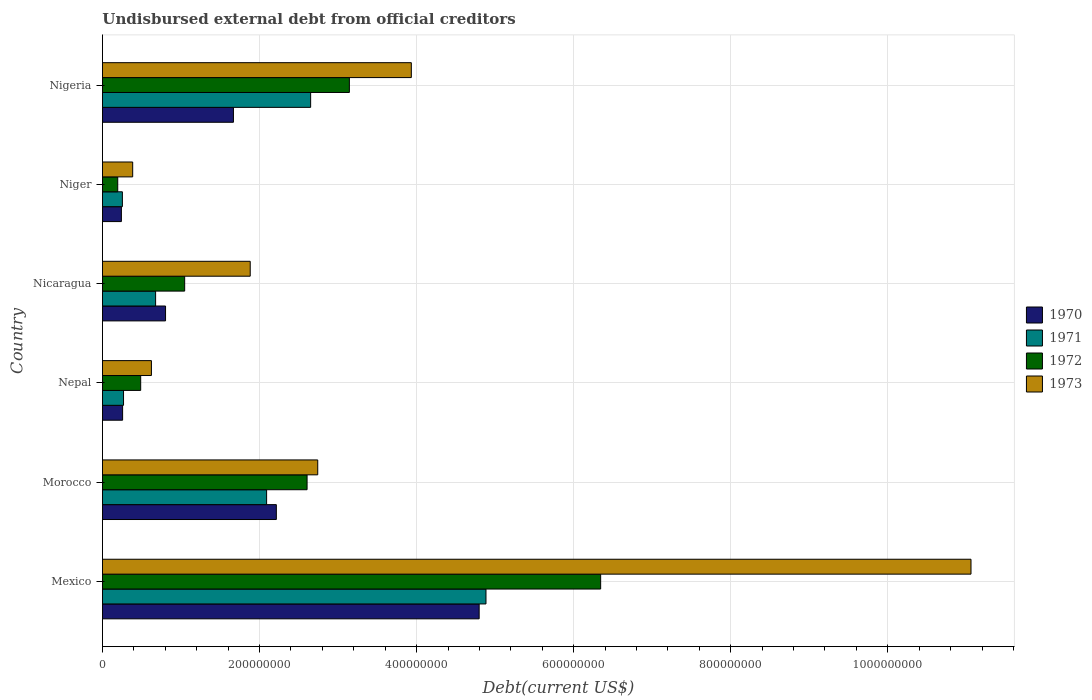How many different coloured bars are there?
Provide a succinct answer. 4. How many groups of bars are there?
Make the answer very short. 6. How many bars are there on the 5th tick from the top?
Provide a succinct answer. 4. What is the label of the 3rd group of bars from the top?
Your answer should be very brief. Nicaragua. In how many cases, is the number of bars for a given country not equal to the number of legend labels?
Make the answer very short. 0. What is the total debt in 1972 in Nigeria?
Your answer should be compact. 3.14e+08. Across all countries, what is the maximum total debt in 1972?
Provide a succinct answer. 6.34e+08. Across all countries, what is the minimum total debt in 1972?
Ensure brevity in your answer.  1.94e+07. In which country was the total debt in 1972 maximum?
Ensure brevity in your answer.  Mexico. In which country was the total debt in 1973 minimum?
Make the answer very short. Niger. What is the total total debt in 1970 in the graph?
Provide a short and direct response. 9.98e+08. What is the difference between the total debt in 1973 in Morocco and that in Nigeria?
Give a very brief answer. -1.19e+08. What is the difference between the total debt in 1970 in Nicaragua and the total debt in 1971 in Mexico?
Your answer should be very brief. -4.08e+08. What is the average total debt in 1970 per country?
Your response must be concise. 1.66e+08. What is the difference between the total debt in 1971 and total debt in 1970 in Nepal?
Your answer should be compact. 1.17e+06. In how many countries, is the total debt in 1971 greater than 920000000 US$?
Offer a very short reply. 0. What is the ratio of the total debt in 1970 in Nicaragua to that in Nigeria?
Provide a short and direct response. 0.48. Is the total debt in 1970 in Morocco less than that in Niger?
Your response must be concise. No. Is the difference between the total debt in 1971 in Nicaragua and Nigeria greater than the difference between the total debt in 1970 in Nicaragua and Nigeria?
Make the answer very short. No. What is the difference between the highest and the second highest total debt in 1971?
Offer a very short reply. 2.23e+08. What is the difference between the highest and the lowest total debt in 1972?
Offer a terse response. 6.15e+08. In how many countries, is the total debt in 1973 greater than the average total debt in 1973 taken over all countries?
Your answer should be very brief. 2. Is the sum of the total debt in 1970 in Nepal and Nigeria greater than the maximum total debt in 1971 across all countries?
Your answer should be compact. No. Is it the case that in every country, the sum of the total debt in 1970 and total debt in 1971 is greater than the total debt in 1972?
Give a very brief answer. Yes. How many countries are there in the graph?
Your answer should be compact. 6. Are the values on the major ticks of X-axis written in scientific E-notation?
Give a very brief answer. No. Does the graph contain any zero values?
Offer a terse response. No. Does the graph contain grids?
Your response must be concise. Yes. How are the legend labels stacked?
Provide a short and direct response. Vertical. What is the title of the graph?
Your response must be concise. Undisbursed external debt from official creditors. Does "2015" appear as one of the legend labels in the graph?
Provide a short and direct response. No. What is the label or title of the X-axis?
Give a very brief answer. Debt(current US$). What is the Debt(current US$) in 1970 in Mexico?
Offer a very short reply. 4.80e+08. What is the Debt(current US$) in 1971 in Mexico?
Provide a short and direct response. 4.88e+08. What is the Debt(current US$) in 1972 in Mexico?
Keep it short and to the point. 6.34e+08. What is the Debt(current US$) of 1973 in Mexico?
Give a very brief answer. 1.11e+09. What is the Debt(current US$) in 1970 in Morocco?
Ensure brevity in your answer.  2.21e+08. What is the Debt(current US$) of 1971 in Morocco?
Your answer should be compact. 2.09e+08. What is the Debt(current US$) of 1972 in Morocco?
Give a very brief answer. 2.61e+08. What is the Debt(current US$) in 1973 in Morocco?
Provide a short and direct response. 2.74e+08. What is the Debt(current US$) in 1970 in Nepal?
Offer a terse response. 2.57e+07. What is the Debt(current US$) in 1971 in Nepal?
Offer a very short reply. 2.68e+07. What is the Debt(current US$) of 1972 in Nepal?
Offer a terse response. 4.87e+07. What is the Debt(current US$) in 1973 in Nepal?
Keep it short and to the point. 6.23e+07. What is the Debt(current US$) in 1970 in Nicaragua?
Offer a terse response. 8.03e+07. What is the Debt(current US$) of 1971 in Nicaragua?
Keep it short and to the point. 6.77e+07. What is the Debt(current US$) of 1972 in Nicaragua?
Offer a very short reply. 1.05e+08. What is the Debt(current US$) of 1973 in Nicaragua?
Offer a terse response. 1.88e+08. What is the Debt(current US$) of 1970 in Niger?
Provide a short and direct response. 2.41e+07. What is the Debt(current US$) of 1971 in Niger?
Make the answer very short. 2.54e+07. What is the Debt(current US$) of 1972 in Niger?
Offer a terse response. 1.94e+07. What is the Debt(current US$) in 1973 in Niger?
Give a very brief answer. 3.85e+07. What is the Debt(current US$) of 1970 in Nigeria?
Give a very brief answer. 1.67e+08. What is the Debt(current US$) of 1971 in Nigeria?
Make the answer very short. 2.65e+08. What is the Debt(current US$) of 1972 in Nigeria?
Offer a very short reply. 3.14e+08. What is the Debt(current US$) of 1973 in Nigeria?
Offer a terse response. 3.93e+08. Across all countries, what is the maximum Debt(current US$) of 1970?
Make the answer very short. 4.80e+08. Across all countries, what is the maximum Debt(current US$) of 1971?
Your answer should be very brief. 4.88e+08. Across all countries, what is the maximum Debt(current US$) of 1972?
Your answer should be compact. 6.34e+08. Across all countries, what is the maximum Debt(current US$) in 1973?
Give a very brief answer. 1.11e+09. Across all countries, what is the minimum Debt(current US$) of 1970?
Your response must be concise. 2.41e+07. Across all countries, what is the minimum Debt(current US$) of 1971?
Keep it short and to the point. 2.54e+07. Across all countries, what is the minimum Debt(current US$) of 1972?
Give a very brief answer. 1.94e+07. Across all countries, what is the minimum Debt(current US$) in 1973?
Make the answer very short. 3.85e+07. What is the total Debt(current US$) of 1970 in the graph?
Ensure brevity in your answer.  9.98e+08. What is the total Debt(current US$) in 1971 in the graph?
Make the answer very short. 1.08e+09. What is the total Debt(current US$) of 1972 in the graph?
Make the answer very short. 1.38e+09. What is the total Debt(current US$) of 1973 in the graph?
Provide a succinct answer. 2.06e+09. What is the difference between the Debt(current US$) of 1970 in Mexico and that in Morocco?
Offer a terse response. 2.58e+08. What is the difference between the Debt(current US$) in 1971 in Mexico and that in Morocco?
Offer a very short reply. 2.79e+08. What is the difference between the Debt(current US$) of 1972 in Mexico and that in Morocco?
Your answer should be compact. 3.74e+08. What is the difference between the Debt(current US$) in 1973 in Mexico and that in Morocco?
Provide a succinct answer. 8.32e+08. What is the difference between the Debt(current US$) in 1970 in Mexico and that in Nepal?
Offer a terse response. 4.54e+08. What is the difference between the Debt(current US$) of 1971 in Mexico and that in Nepal?
Provide a short and direct response. 4.62e+08. What is the difference between the Debt(current US$) of 1972 in Mexico and that in Nepal?
Offer a terse response. 5.86e+08. What is the difference between the Debt(current US$) of 1973 in Mexico and that in Nepal?
Provide a succinct answer. 1.04e+09. What is the difference between the Debt(current US$) of 1970 in Mexico and that in Nicaragua?
Your response must be concise. 3.99e+08. What is the difference between the Debt(current US$) in 1971 in Mexico and that in Nicaragua?
Offer a terse response. 4.21e+08. What is the difference between the Debt(current US$) in 1972 in Mexico and that in Nicaragua?
Provide a short and direct response. 5.30e+08. What is the difference between the Debt(current US$) in 1973 in Mexico and that in Nicaragua?
Provide a short and direct response. 9.18e+08. What is the difference between the Debt(current US$) of 1970 in Mexico and that in Niger?
Your response must be concise. 4.56e+08. What is the difference between the Debt(current US$) of 1971 in Mexico and that in Niger?
Keep it short and to the point. 4.63e+08. What is the difference between the Debt(current US$) in 1972 in Mexico and that in Niger?
Ensure brevity in your answer.  6.15e+08. What is the difference between the Debt(current US$) of 1973 in Mexico and that in Niger?
Your answer should be very brief. 1.07e+09. What is the difference between the Debt(current US$) in 1970 in Mexico and that in Nigeria?
Provide a short and direct response. 3.13e+08. What is the difference between the Debt(current US$) of 1971 in Mexico and that in Nigeria?
Offer a very short reply. 2.23e+08. What is the difference between the Debt(current US$) in 1972 in Mexico and that in Nigeria?
Your answer should be very brief. 3.20e+08. What is the difference between the Debt(current US$) in 1973 in Mexico and that in Nigeria?
Give a very brief answer. 7.13e+08. What is the difference between the Debt(current US$) in 1970 in Morocco and that in Nepal?
Ensure brevity in your answer.  1.96e+08. What is the difference between the Debt(current US$) in 1971 in Morocco and that in Nepal?
Give a very brief answer. 1.82e+08. What is the difference between the Debt(current US$) of 1972 in Morocco and that in Nepal?
Your answer should be compact. 2.12e+08. What is the difference between the Debt(current US$) in 1973 in Morocco and that in Nepal?
Offer a very short reply. 2.12e+08. What is the difference between the Debt(current US$) of 1970 in Morocco and that in Nicaragua?
Provide a succinct answer. 1.41e+08. What is the difference between the Debt(current US$) in 1971 in Morocco and that in Nicaragua?
Offer a very short reply. 1.41e+08. What is the difference between the Debt(current US$) in 1972 in Morocco and that in Nicaragua?
Offer a very short reply. 1.56e+08. What is the difference between the Debt(current US$) in 1973 in Morocco and that in Nicaragua?
Offer a very short reply. 8.60e+07. What is the difference between the Debt(current US$) of 1970 in Morocco and that in Niger?
Your answer should be very brief. 1.97e+08. What is the difference between the Debt(current US$) of 1971 in Morocco and that in Niger?
Provide a succinct answer. 1.84e+08. What is the difference between the Debt(current US$) of 1972 in Morocco and that in Niger?
Offer a terse response. 2.41e+08. What is the difference between the Debt(current US$) of 1973 in Morocco and that in Niger?
Give a very brief answer. 2.36e+08. What is the difference between the Debt(current US$) in 1970 in Morocco and that in Nigeria?
Your answer should be compact. 5.46e+07. What is the difference between the Debt(current US$) in 1971 in Morocco and that in Nigeria?
Your response must be concise. -5.61e+07. What is the difference between the Debt(current US$) in 1972 in Morocco and that in Nigeria?
Your answer should be very brief. -5.39e+07. What is the difference between the Debt(current US$) of 1973 in Morocco and that in Nigeria?
Offer a terse response. -1.19e+08. What is the difference between the Debt(current US$) of 1970 in Nepal and that in Nicaragua?
Your response must be concise. -5.47e+07. What is the difference between the Debt(current US$) in 1971 in Nepal and that in Nicaragua?
Provide a short and direct response. -4.08e+07. What is the difference between the Debt(current US$) in 1972 in Nepal and that in Nicaragua?
Keep it short and to the point. -5.60e+07. What is the difference between the Debt(current US$) in 1973 in Nepal and that in Nicaragua?
Offer a very short reply. -1.26e+08. What is the difference between the Debt(current US$) in 1970 in Nepal and that in Niger?
Your response must be concise. 1.55e+06. What is the difference between the Debt(current US$) in 1971 in Nepal and that in Niger?
Offer a terse response. 1.45e+06. What is the difference between the Debt(current US$) of 1972 in Nepal and that in Niger?
Provide a succinct answer. 2.92e+07. What is the difference between the Debt(current US$) of 1973 in Nepal and that in Niger?
Give a very brief answer. 2.39e+07. What is the difference between the Debt(current US$) of 1970 in Nepal and that in Nigeria?
Offer a very short reply. -1.41e+08. What is the difference between the Debt(current US$) of 1971 in Nepal and that in Nigeria?
Your response must be concise. -2.38e+08. What is the difference between the Debt(current US$) in 1972 in Nepal and that in Nigeria?
Keep it short and to the point. -2.66e+08. What is the difference between the Debt(current US$) in 1973 in Nepal and that in Nigeria?
Offer a terse response. -3.31e+08. What is the difference between the Debt(current US$) in 1970 in Nicaragua and that in Niger?
Give a very brief answer. 5.62e+07. What is the difference between the Debt(current US$) in 1971 in Nicaragua and that in Niger?
Your answer should be very brief. 4.23e+07. What is the difference between the Debt(current US$) in 1972 in Nicaragua and that in Niger?
Ensure brevity in your answer.  8.52e+07. What is the difference between the Debt(current US$) of 1973 in Nicaragua and that in Niger?
Offer a very short reply. 1.50e+08. What is the difference between the Debt(current US$) of 1970 in Nicaragua and that in Nigeria?
Offer a terse response. -8.65e+07. What is the difference between the Debt(current US$) in 1971 in Nicaragua and that in Nigeria?
Provide a succinct answer. -1.97e+08. What is the difference between the Debt(current US$) in 1972 in Nicaragua and that in Nigeria?
Provide a short and direct response. -2.10e+08. What is the difference between the Debt(current US$) in 1973 in Nicaragua and that in Nigeria?
Make the answer very short. -2.05e+08. What is the difference between the Debt(current US$) in 1970 in Niger and that in Nigeria?
Your response must be concise. -1.43e+08. What is the difference between the Debt(current US$) in 1971 in Niger and that in Nigeria?
Provide a succinct answer. -2.40e+08. What is the difference between the Debt(current US$) in 1972 in Niger and that in Nigeria?
Your answer should be compact. -2.95e+08. What is the difference between the Debt(current US$) in 1973 in Niger and that in Nigeria?
Provide a succinct answer. -3.55e+08. What is the difference between the Debt(current US$) in 1970 in Mexico and the Debt(current US$) in 1971 in Morocco?
Keep it short and to the point. 2.71e+08. What is the difference between the Debt(current US$) of 1970 in Mexico and the Debt(current US$) of 1972 in Morocco?
Keep it short and to the point. 2.19e+08. What is the difference between the Debt(current US$) of 1970 in Mexico and the Debt(current US$) of 1973 in Morocco?
Your answer should be very brief. 2.06e+08. What is the difference between the Debt(current US$) of 1971 in Mexico and the Debt(current US$) of 1972 in Morocco?
Give a very brief answer. 2.28e+08. What is the difference between the Debt(current US$) in 1971 in Mexico and the Debt(current US$) in 1973 in Morocco?
Your answer should be compact. 2.14e+08. What is the difference between the Debt(current US$) of 1972 in Mexico and the Debt(current US$) of 1973 in Morocco?
Give a very brief answer. 3.60e+08. What is the difference between the Debt(current US$) of 1970 in Mexico and the Debt(current US$) of 1971 in Nepal?
Offer a very short reply. 4.53e+08. What is the difference between the Debt(current US$) in 1970 in Mexico and the Debt(current US$) in 1972 in Nepal?
Your response must be concise. 4.31e+08. What is the difference between the Debt(current US$) in 1970 in Mexico and the Debt(current US$) in 1973 in Nepal?
Ensure brevity in your answer.  4.17e+08. What is the difference between the Debt(current US$) of 1971 in Mexico and the Debt(current US$) of 1972 in Nepal?
Make the answer very short. 4.40e+08. What is the difference between the Debt(current US$) in 1971 in Mexico and the Debt(current US$) in 1973 in Nepal?
Offer a very short reply. 4.26e+08. What is the difference between the Debt(current US$) of 1972 in Mexico and the Debt(current US$) of 1973 in Nepal?
Ensure brevity in your answer.  5.72e+08. What is the difference between the Debt(current US$) in 1970 in Mexico and the Debt(current US$) in 1971 in Nicaragua?
Your response must be concise. 4.12e+08. What is the difference between the Debt(current US$) in 1970 in Mexico and the Debt(current US$) in 1972 in Nicaragua?
Make the answer very short. 3.75e+08. What is the difference between the Debt(current US$) in 1970 in Mexico and the Debt(current US$) in 1973 in Nicaragua?
Provide a short and direct response. 2.92e+08. What is the difference between the Debt(current US$) in 1971 in Mexico and the Debt(current US$) in 1972 in Nicaragua?
Give a very brief answer. 3.84e+08. What is the difference between the Debt(current US$) of 1971 in Mexico and the Debt(current US$) of 1973 in Nicaragua?
Provide a succinct answer. 3.00e+08. What is the difference between the Debt(current US$) in 1972 in Mexico and the Debt(current US$) in 1973 in Nicaragua?
Keep it short and to the point. 4.46e+08. What is the difference between the Debt(current US$) in 1970 in Mexico and the Debt(current US$) in 1971 in Niger?
Offer a very short reply. 4.54e+08. What is the difference between the Debt(current US$) of 1970 in Mexico and the Debt(current US$) of 1972 in Niger?
Keep it short and to the point. 4.60e+08. What is the difference between the Debt(current US$) of 1970 in Mexico and the Debt(current US$) of 1973 in Niger?
Your answer should be very brief. 4.41e+08. What is the difference between the Debt(current US$) in 1971 in Mexico and the Debt(current US$) in 1972 in Niger?
Your answer should be very brief. 4.69e+08. What is the difference between the Debt(current US$) of 1971 in Mexico and the Debt(current US$) of 1973 in Niger?
Your answer should be very brief. 4.50e+08. What is the difference between the Debt(current US$) of 1972 in Mexico and the Debt(current US$) of 1973 in Niger?
Your answer should be very brief. 5.96e+08. What is the difference between the Debt(current US$) in 1970 in Mexico and the Debt(current US$) in 1971 in Nigeria?
Provide a succinct answer. 2.15e+08. What is the difference between the Debt(current US$) in 1970 in Mexico and the Debt(current US$) in 1972 in Nigeria?
Provide a succinct answer. 1.65e+08. What is the difference between the Debt(current US$) in 1970 in Mexico and the Debt(current US$) in 1973 in Nigeria?
Make the answer very short. 8.64e+07. What is the difference between the Debt(current US$) of 1971 in Mexico and the Debt(current US$) of 1972 in Nigeria?
Make the answer very short. 1.74e+08. What is the difference between the Debt(current US$) of 1971 in Mexico and the Debt(current US$) of 1973 in Nigeria?
Ensure brevity in your answer.  9.51e+07. What is the difference between the Debt(current US$) in 1972 in Mexico and the Debt(current US$) in 1973 in Nigeria?
Ensure brevity in your answer.  2.41e+08. What is the difference between the Debt(current US$) in 1970 in Morocco and the Debt(current US$) in 1971 in Nepal?
Provide a succinct answer. 1.95e+08. What is the difference between the Debt(current US$) in 1970 in Morocco and the Debt(current US$) in 1972 in Nepal?
Provide a short and direct response. 1.73e+08. What is the difference between the Debt(current US$) in 1970 in Morocco and the Debt(current US$) in 1973 in Nepal?
Your response must be concise. 1.59e+08. What is the difference between the Debt(current US$) of 1971 in Morocco and the Debt(current US$) of 1972 in Nepal?
Ensure brevity in your answer.  1.60e+08. What is the difference between the Debt(current US$) of 1971 in Morocco and the Debt(current US$) of 1973 in Nepal?
Give a very brief answer. 1.47e+08. What is the difference between the Debt(current US$) of 1972 in Morocco and the Debt(current US$) of 1973 in Nepal?
Your response must be concise. 1.98e+08. What is the difference between the Debt(current US$) in 1970 in Morocco and the Debt(current US$) in 1971 in Nicaragua?
Your answer should be compact. 1.54e+08. What is the difference between the Debt(current US$) in 1970 in Morocco and the Debt(current US$) in 1972 in Nicaragua?
Your answer should be very brief. 1.17e+08. What is the difference between the Debt(current US$) in 1970 in Morocco and the Debt(current US$) in 1973 in Nicaragua?
Give a very brief answer. 3.33e+07. What is the difference between the Debt(current US$) of 1971 in Morocco and the Debt(current US$) of 1972 in Nicaragua?
Your answer should be very brief. 1.04e+08. What is the difference between the Debt(current US$) in 1971 in Morocco and the Debt(current US$) in 1973 in Nicaragua?
Keep it short and to the point. 2.09e+07. What is the difference between the Debt(current US$) of 1972 in Morocco and the Debt(current US$) of 1973 in Nicaragua?
Your response must be concise. 7.24e+07. What is the difference between the Debt(current US$) in 1970 in Morocco and the Debt(current US$) in 1971 in Niger?
Provide a succinct answer. 1.96e+08. What is the difference between the Debt(current US$) of 1970 in Morocco and the Debt(current US$) of 1972 in Niger?
Provide a succinct answer. 2.02e+08. What is the difference between the Debt(current US$) in 1970 in Morocco and the Debt(current US$) in 1973 in Niger?
Make the answer very short. 1.83e+08. What is the difference between the Debt(current US$) of 1971 in Morocco and the Debt(current US$) of 1972 in Niger?
Offer a terse response. 1.90e+08. What is the difference between the Debt(current US$) of 1971 in Morocco and the Debt(current US$) of 1973 in Niger?
Offer a very short reply. 1.71e+08. What is the difference between the Debt(current US$) in 1972 in Morocco and the Debt(current US$) in 1973 in Niger?
Make the answer very short. 2.22e+08. What is the difference between the Debt(current US$) in 1970 in Morocco and the Debt(current US$) in 1971 in Nigeria?
Offer a terse response. -4.37e+07. What is the difference between the Debt(current US$) in 1970 in Morocco and the Debt(current US$) in 1972 in Nigeria?
Provide a short and direct response. -9.30e+07. What is the difference between the Debt(current US$) in 1970 in Morocco and the Debt(current US$) in 1973 in Nigeria?
Provide a short and direct response. -1.72e+08. What is the difference between the Debt(current US$) of 1971 in Morocco and the Debt(current US$) of 1972 in Nigeria?
Offer a very short reply. -1.05e+08. What is the difference between the Debt(current US$) of 1971 in Morocco and the Debt(current US$) of 1973 in Nigeria?
Provide a succinct answer. -1.84e+08. What is the difference between the Debt(current US$) of 1972 in Morocco and the Debt(current US$) of 1973 in Nigeria?
Keep it short and to the point. -1.33e+08. What is the difference between the Debt(current US$) of 1970 in Nepal and the Debt(current US$) of 1971 in Nicaragua?
Your response must be concise. -4.20e+07. What is the difference between the Debt(current US$) of 1970 in Nepal and the Debt(current US$) of 1972 in Nicaragua?
Give a very brief answer. -7.90e+07. What is the difference between the Debt(current US$) in 1970 in Nepal and the Debt(current US$) in 1973 in Nicaragua?
Make the answer very short. -1.62e+08. What is the difference between the Debt(current US$) in 1971 in Nepal and the Debt(current US$) in 1972 in Nicaragua?
Offer a very short reply. -7.78e+07. What is the difference between the Debt(current US$) of 1971 in Nepal and the Debt(current US$) of 1973 in Nicaragua?
Offer a very short reply. -1.61e+08. What is the difference between the Debt(current US$) in 1972 in Nepal and the Debt(current US$) in 1973 in Nicaragua?
Your response must be concise. -1.39e+08. What is the difference between the Debt(current US$) in 1970 in Nepal and the Debt(current US$) in 1971 in Niger?
Make the answer very short. 2.78e+05. What is the difference between the Debt(current US$) of 1970 in Nepal and the Debt(current US$) of 1972 in Niger?
Your response must be concise. 6.20e+06. What is the difference between the Debt(current US$) of 1970 in Nepal and the Debt(current US$) of 1973 in Niger?
Offer a terse response. -1.28e+07. What is the difference between the Debt(current US$) of 1971 in Nepal and the Debt(current US$) of 1972 in Niger?
Provide a succinct answer. 7.37e+06. What is the difference between the Debt(current US$) in 1971 in Nepal and the Debt(current US$) in 1973 in Niger?
Give a very brief answer. -1.17e+07. What is the difference between the Debt(current US$) in 1972 in Nepal and the Debt(current US$) in 1973 in Niger?
Your answer should be very brief. 1.02e+07. What is the difference between the Debt(current US$) in 1970 in Nepal and the Debt(current US$) in 1971 in Nigeria?
Keep it short and to the point. -2.39e+08. What is the difference between the Debt(current US$) in 1970 in Nepal and the Debt(current US$) in 1972 in Nigeria?
Offer a very short reply. -2.89e+08. What is the difference between the Debt(current US$) of 1970 in Nepal and the Debt(current US$) of 1973 in Nigeria?
Provide a succinct answer. -3.68e+08. What is the difference between the Debt(current US$) in 1971 in Nepal and the Debt(current US$) in 1972 in Nigeria?
Give a very brief answer. -2.88e+08. What is the difference between the Debt(current US$) of 1971 in Nepal and the Debt(current US$) of 1973 in Nigeria?
Provide a succinct answer. -3.66e+08. What is the difference between the Debt(current US$) in 1972 in Nepal and the Debt(current US$) in 1973 in Nigeria?
Provide a succinct answer. -3.45e+08. What is the difference between the Debt(current US$) of 1970 in Nicaragua and the Debt(current US$) of 1971 in Niger?
Your response must be concise. 5.49e+07. What is the difference between the Debt(current US$) of 1970 in Nicaragua and the Debt(current US$) of 1972 in Niger?
Your answer should be very brief. 6.09e+07. What is the difference between the Debt(current US$) of 1970 in Nicaragua and the Debt(current US$) of 1973 in Niger?
Ensure brevity in your answer.  4.18e+07. What is the difference between the Debt(current US$) of 1971 in Nicaragua and the Debt(current US$) of 1972 in Niger?
Ensure brevity in your answer.  4.82e+07. What is the difference between the Debt(current US$) of 1971 in Nicaragua and the Debt(current US$) of 1973 in Niger?
Keep it short and to the point. 2.92e+07. What is the difference between the Debt(current US$) of 1972 in Nicaragua and the Debt(current US$) of 1973 in Niger?
Provide a short and direct response. 6.62e+07. What is the difference between the Debt(current US$) of 1970 in Nicaragua and the Debt(current US$) of 1971 in Nigeria?
Offer a terse response. -1.85e+08. What is the difference between the Debt(current US$) of 1970 in Nicaragua and the Debt(current US$) of 1972 in Nigeria?
Your answer should be compact. -2.34e+08. What is the difference between the Debt(current US$) of 1970 in Nicaragua and the Debt(current US$) of 1973 in Nigeria?
Give a very brief answer. -3.13e+08. What is the difference between the Debt(current US$) in 1971 in Nicaragua and the Debt(current US$) in 1972 in Nigeria?
Your response must be concise. -2.47e+08. What is the difference between the Debt(current US$) in 1971 in Nicaragua and the Debt(current US$) in 1973 in Nigeria?
Ensure brevity in your answer.  -3.26e+08. What is the difference between the Debt(current US$) of 1972 in Nicaragua and the Debt(current US$) of 1973 in Nigeria?
Offer a very short reply. -2.89e+08. What is the difference between the Debt(current US$) in 1970 in Niger and the Debt(current US$) in 1971 in Nigeria?
Keep it short and to the point. -2.41e+08. What is the difference between the Debt(current US$) of 1970 in Niger and the Debt(current US$) of 1972 in Nigeria?
Ensure brevity in your answer.  -2.90e+08. What is the difference between the Debt(current US$) in 1970 in Niger and the Debt(current US$) in 1973 in Nigeria?
Offer a terse response. -3.69e+08. What is the difference between the Debt(current US$) in 1971 in Niger and the Debt(current US$) in 1972 in Nigeria?
Your response must be concise. -2.89e+08. What is the difference between the Debt(current US$) in 1971 in Niger and the Debt(current US$) in 1973 in Nigeria?
Make the answer very short. -3.68e+08. What is the difference between the Debt(current US$) of 1972 in Niger and the Debt(current US$) of 1973 in Nigeria?
Offer a terse response. -3.74e+08. What is the average Debt(current US$) of 1970 per country?
Offer a very short reply. 1.66e+08. What is the average Debt(current US$) of 1971 per country?
Offer a terse response. 1.80e+08. What is the average Debt(current US$) in 1972 per country?
Provide a short and direct response. 2.30e+08. What is the average Debt(current US$) in 1973 per country?
Your answer should be very brief. 3.44e+08. What is the difference between the Debt(current US$) of 1970 and Debt(current US$) of 1971 in Mexico?
Your answer should be very brief. -8.70e+06. What is the difference between the Debt(current US$) in 1970 and Debt(current US$) in 1972 in Mexico?
Your answer should be very brief. -1.55e+08. What is the difference between the Debt(current US$) of 1970 and Debt(current US$) of 1973 in Mexico?
Give a very brief answer. -6.26e+08. What is the difference between the Debt(current US$) of 1971 and Debt(current US$) of 1972 in Mexico?
Provide a short and direct response. -1.46e+08. What is the difference between the Debt(current US$) of 1971 and Debt(current US$) of 1973 in Mexico?
Offer a terse response. -6.18e+08. What is the difference between the Debt(current US$) in 1972 and Debt(current US$) in 1973 in Mexico?
Offer a terse response. -4.72e+08. What is the difference between the Debt(current US$) of 1970 and Debt(current US$) of 1971 in Morocco?
Keep it short and to the point. 1.24e+07. What is the difference between the Debt(current US$) of 1970 and Debt(current US$) of 1972 in Morocco?
Ensure brevity in your answer.  -3.91e+07. What is the difference between the Debt(current US$) in 1970 and Debt(current US$) in 1973 in Morocco?
Give a very brief answer. -5.27e+07. What is the difference between the Debt(current US$) of 1971 and Debt(current US$) of 1972 in Morocco?
Make the answer very short. -5.15e+07. What is the difference between the Debt(current US$) in 1971 and Debt(current US$) in 1973 in Morocco?
Your answer should be very brief. -6.51e+07. What is the difference between the Debt(current US$) in 1972 and Debt(current US$) in 1973 in Morocco?
Provide a succinct answer. -1.36e+07. What is the difference between the Debt(current US$) of 1970 and Debt(current US$) of 1971 in Nepal?
Offer a terse response. -1.17e+06. What is the difference between the Debt(current US$) of 1970 and Debt(current US$) of 1972 in Nepal?
Ensure brevity in your answer.  -2.30e+07. What is the difference between the Debt(current US$) of 1970 and Debt(current US$) of 1973 in Nepal?
Your answer should be compact. -3.67e+07. What is the difference between the Debt(current US$) of 1971 and Debt(current US$) of 1972 in Nepal?
Your response must be concise. -2.18e+07. What is the difference between the Debt(current US$) of 1971 and Debt(current US$) of 1973 in Nepal?
Provide a short and direct response. -3.55e+07. What is the difference between the Debt(current US$) of 1972 and Debt(current US$) of 1973 in Nepal?
Your answer should be compact. -1.37e+07. What is the difference between the Debt(current US$) of 1970 and Debt(current US$) of 1971 in Nicaragua?
Offer a very short reply. 1.26e+07. What is the difference between the Debt(current US$) in 1970 and Debt(current US$) in 1972 in Nicaragua?
Your answer should be compact. -2.44e+07. What is the difference between the Debt(current US$) in 1970 and Debt(current US$) in 1973 in Nicaragua?
Keep it short and to the point. -1.08e+08. What is the difference between the Debt(current US$) of 1971 and Debt(current US$) of 1972 in Nicaragua?
Provide a short and direct response. -3.70e+07. What is the difference between the Debt(current US$) in 1971 and Debt(current US$) in 1973 in Nicaragua?
Ensure brevity in your answer.  -1.20e+08. What is the difference between the Debt(current US$) of 1972 and Debt(current US$) of 1973 in Nicaragua?
Offer a terse response. -8.35e+07. What is the difference between the Debt(current US$) in 1970 and Debt(current US$) in 1971 in Niger?
Your answer should be compact. -1.28e+06. What is the difference between the Debt(current US$) of 1970 and Debt(current US$) of 1972 in Niger?
Offer a terse response. 4.65e+06. What is the difference between the Debt(current US$) of 1970 and Debt(current US$) of 1973 in Niger?
Provide a succinct answer. -1.44e+07. What is the difference between the Debt(current US$) in 1971 and Debt(current US$) in 1972 in Niger?
Provide a succinct answer. 5.93e+06. What is the difference between the Debt(current US$) in 1971 and Debt(current US$) in 1973 in Niger?
Offer a very short reply. -1.31e+07. What is the difference between the Debt(current US$) in 1972 and Debt(current US$) in 1973 in Niger?
Provide a succinct answer. -1.90e+07. What is the difference between the Debt(current US$) of 1970 and Debt(current US$) of 1971 in Nigeria?
Your answer should be compact. -9.83e+07. What is the difference between the Debt(current US$) of 1970 and Debt(current US$) of 1972 in Nigeria?
Your answer should be very brief. -1.48e+08. What is the difference between the Debt(current US$) in 1970 and Debt(current US$) in 1973 in Nigeria?
Offer a very short reply. -2.27e+08. What is the difference between the Debt(current US$) in 1971 and Debt(current US$) in 1972 in Nigeria?
Keep it short and to the point. -4.93e+07. What is the difference between the Debt(current US$) of 1971 and Debt(current US$) of 1973 in Nigeria?
Offer a terse response. -1.28e+08. What is the difference between the Debt(current US$) of 1972 and Debt(current US$) of 1973 in Nigeria?
Your response must be concise. -7.89e+07. What is the ratio of the Debt(current US$) in 1970 in Mexico to that in Morocco?
Your answer should be compact. 2.17. What is the ratio of the Debt(current US$) in 1971 in Mexico to that in Morocco?
Provide a short and direct response. 2.34. What is the ratio of the Debt(current US$) in 1972 in Mexico to that in Morocco?
Offer a terse response. 2.43. What is the ratio of the Debt(current US$) of 1973 in Mexico to that in Morocco?
Your response must be concise. 4.03. What is the ratio of the Debt(current US$) of 1970 in Mexico to that in Nepal?
Your answer should be compact. 18.7. What is the ratio of the Debt(current US$) in 1971 in Mexico to that in Nepal?
Ensure brevity in your answer.  18.21. What is the ratio of the Debt(current US$) in 1972 in Mexico to that in Nepal?
Provide a short and direct response. 13.04. What is the ratio of the Debt(current US$) of 1973 in Mexico to that in Nepal?
Give a very brief answer. 17.74. What is the ratio of the Debt(current US$) of 1970 in Mexico to that in Nicaragua?
Offer a terse response. 5.97. What is the ratio of the Debt(current US$) of 1971 in Mexico to that in Nicaragua?
Provide a short and direct response. 7.22. What is the ratio of the Debt(current US$) in 1972 in Mexico to that in Nicaragua?
Your answer should be compact. 6.06. What is the ratio of the Debt(current US$) of 1973 in Mexico to that in Nicaragua?
Provide a short and direct response. 5.88. What is the ratio of the Debt(current US$) of 1970 in Mexico to that in Niger?
Give a very brief answer. 19.9. What is the ratio of the Debt(current US$) of 1971 in Mexico to that in Niger?
Ensure brevity in your answer.  19.25. What is the ratio of the Debt(current US$) in 1972 in Mexico to that in Niger?
Provide a short and direct response. 32.62. What is the ratio of the Debt(current US$) of 1973 in Mexico to that in Niger?
Offer a very short reply. 28.74. What is the ratio of the Debt(current US$) in 1970 in Mexico to that in Nigeria?
Provide a short and direct response. 2.88. What is the ratio of the Debt(current US$) in 1971 in Mexico to that in Nigeria?
Offer a very short reply. 1.84. What is the ratio of the Debt(current US$) in 1972 in Mexico to that in Nigeria?
Make the answer very short. 2.02. What is the ratio of the Debt(current US$) in 1973 in Mexico to that in Nigeria?
Ensure brevity in your answer.  2.81. What is the ratio of the Debt(current US$) of 1970 in Morocco to that in Nepal?
Give a very brief answer. 8.63. What is the ratio of the Debt(current US$) of 1971 in Morocco to that in Nepal?
Your response must be concise. 7.79. What is the ratio of the Debt(current US$) in 1972 in Morocco to that in Nepal?
Offer a terse response. 5.35. What is the ratio of the Debt(current US$) of 1973 in Morocco to that in Nepal?
Your answer should be very brief. 4.4. What is the ratio of the Debt(current US$) of 1970 in Morocco to that in Nicaragua?
Your answer should be very brief. 2.76. What is the ratio of the Debt(current US$) of 1971 in Morocco to that in Nicaragua?
Offer a terse response. 3.09. What is the ratio of the Debt(current US$) in 1972 in Morocco to that in Nicaragua?
Your answer should be compact. 2.49. What is the ratio of the Debt(current US$) in 1973 in Morocco to that in Nicaragua?
Your response must be concise. 1.46. What is the ratio of the Debt(current US$) in 1970 in Morocco to that in Niger?
Give a very brief answer. 9.19. What is the ratio of the Debt(current US$) of 1971 in Morocco to that in Niger?
Make the answer very short. 8.24. What is the ratio of the Debt(current US$) in 1972 in Morocco to that in Niger?
Your answer should be very brief. 13.4. What is the ratio of the Debt(current US$) in 1973 in Morocco to that in Niger?
Give a very brief answer. 7.12. What is the ratio of the Debt(current US$) in 1970 in Morocco to that in Nigeria?
Offer a very short reply. 1.33. What is the ratio of the Debt(current US$) of 1971 in Morocco to that in Nigeria?
Provide a succinct answer. 0.79. What is the ratio of the Debt(current US$) in 1972 in Morocco to that in Nigeria?
Provide a short and direct response. 0.83. What is the ratio of the Debt(current US$) in 1973 in Morocco to that in Nigeria?
Keep it short and to the point. 0.7. What is the ratio of the Debt(current US$) in 1970 in Nepal to that in Nicaragua?
Ensure brevity in your answer.  0.32. What is the ratio of the Debt(current US$) of 1971 in Nepal to that in Nicaragua?
Make the answer very short. 0.4. What is the ratio of the Debt(current US$) in 1972 in Nepal to that in Nicaragua?
Your answer should be compact. 0.46. What is the ratio of the Debt(current US$) in 1973 in Nepal to that in Nicaragua?
Your answer should be very brief. 0.33. What is the ratio of the Debt(current US$) of 1970 in Nepal to that in Niger?
Your answer should be compact. 1.06. What is the ratio of the Debt(current US$) of 1971 in Nepal to that in Niger?
Offer a very short reply. 1.06. What is the ratio of the Debt(current US$) of 1972 in Nepal to that in Niger?
Give a very brief answer. 2.5. What is the ratio of the Debt(current US$) in 1973 in Nepal to that in Niger?
Your answer should be compact. 1.62. What is the ratio of the Debt(current US$) of 1970 in Nepal to that in Nigeria?
Give a very brief answer. 0.15. What is the ratio of the Debt(current US$) in 1971 in Nepal to that in Nigeria?
Provide a succinct answer. 0.1. What is the ratio of the Debt(current US$) of 1972 in Nepal to that in Nigeria?
Offer a terse response. 0.15. What is the ratio of the Debt(current US$) in 1973 in Nepal to that in Nigeria?
Offer a very short reply. 0.16. What is the ratio of the Debt(current US$) of 1970 in Nicaragua to that in Niger?
Provide a succinct answer. 3.33. What is the ratio of the Debt(current US$) of 1971 in Nicaragua to that in Niger?
Keep it short and to the point. 2.67. What is the ratio of the Debt(current US$) in 1972 in Nicaragua to that in Niger?
Make the answer very short. 5.38. What is the ratio of the Debt(current US$) in 1973 in Nicaragua to that in Niger?
Offer a very short reply. 4.89. What is the ratio of the Debt(current US$) in 1970 in Nicaragua to that in Nigeria?
Provide a short and direct response. 0.48. What is the ratio of the Debt(current US$) in 1971 in Nicaragua to that in Nigeria?
Provide a succinct answer. 0.26. What is the ratio of the Debt(current US$) of 1972 in Nicaragua to that in Nigeria?
Offer a very short reply. 0.33. What is the ratio of the Debt(current US$) in 1973 in Nicaragua to that in Nigeria?
Ensure brevity in your answer.  0.48. What is the ratio of the Debt(current US$) of 1970 in Niger to that in Nigeria?
Keep it short and to the point. 0.14. What is the ratio of the Debt(current US$) in 1971 in Niger to that in Nigeria?
Your answer should be compact. 0.1. What is the ratio of the Debt(current US$) of 1972 in Niger to that in Nigeria?
Your answer should be very brief. 0.06. What is the ratio of the Debt(current US$) of 1973 in Niger to that in Nigeria?
Your response must be concise. 0.1. What is the difference between the highest and the second highest Debt(current US$) in 1970?
Make the answer very short. 2.58e+08. What is the difference between the highest and the second highest Debt(current US$) of 1971?
Keep it short and to the point. 2.23e+08. What is the difference between the highest and the second highest Debt(current US$) in 1972?
Provide a short and direct response. 3.20e+08. What is the difference between the highest and the second highest Debt(current US$) in 1973?
Provide a short and direct response. 7.13e+08. What is the difference between the highest and the lowest Debt(current US$) in 1970?
Ensure brevity in your answer.  4.56e+08. What is the difference between the highest and the lowest Debt(current US$) in 1971?
Your response must be concise. 4.63e+08. What is the difference between the highest and the lowest Debt(current US$) of 1972?
Give a very brief answer. 6.15e+08. What is the difference between the highest and the lowest Debt(current US$) in 1973?
Make the answer very short. 1.07e+09. 